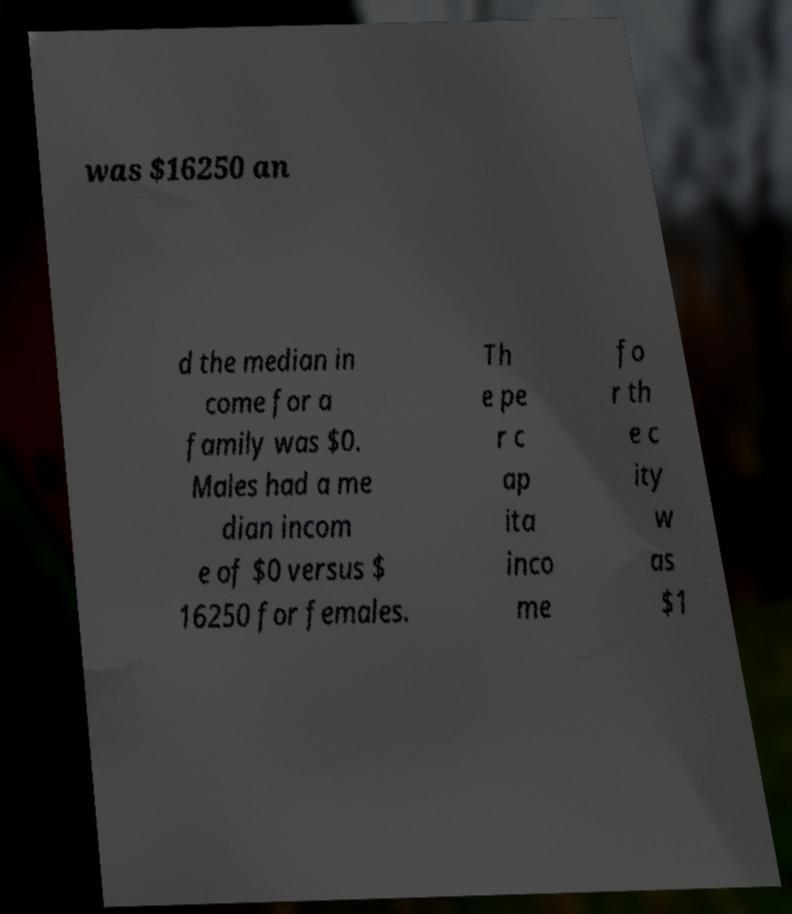I need the written content from this picture converted into text. Can you do that? was $16250 an d the median in come for a family was $0. Males had a me dian incom e of $0 versus $ 16250 for females. Th e pe r c ap ita inco me fo r th e c ity w as $1 